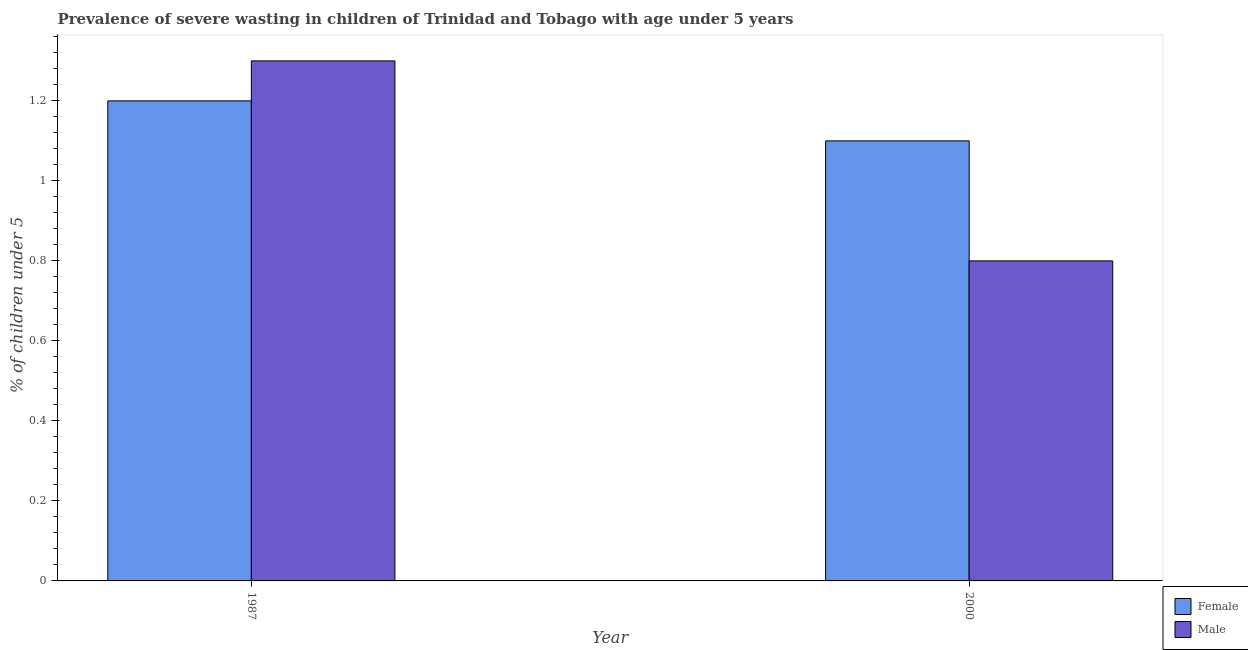How many different coloured bars are there?
Make the answer very short. 2. Are the number of bars per tick equal to the number of legend labels?
Your answer should be very brief. Yes. How many bars are there on the 1st tick from the right?
Give a very brief answer. 2. In how many cases, is the number of bars for a given year not equal to the number of legend labels?
Your answer should be very brief. 0. What is the percentage of undernourished female children in 1987?
Your response must be concise. 1.2. Across all years, what is the maximum percentage of undernourished male children?
Make the answer very short. 1.3. Across all years, what is the minimum percentage of undernourished female children?
Provide a short and direct response. 1.1. In which year was the percentage of undernourished female children maximum?
Make the answer very short. 1987. In which year was the percentage of undernourished male children minimum?
Your answer should be compact. 2000. What is the total percentage of undernourished male children in the graph?
Your answer should be compact. 2.1. What is the difference between the percentage of undernourished female children in 1987 and that in 2000?
Give a very brief answer. 0.1. What is the difference between the percentage of undernourished male children in 1987 and the percentage of undernourished female children in 2000?
Keep it short and to the point. 0.5. What is the average percentage of undernourished female children per year?
Your answer should be compact. 1.15. What is the ratio of the percentage of undernourished female children in 1987 to that in 2000?
Ensure brevity in your answer.  1.09. In how many years, is the percentage of undernourished male children greater than the average percentage of undernourished male children taken over all years?
Ensure brevity in your answer.  1. What does the 1st bar from the left in 1987 represents?
Make the answer very short. Female. What is the difference between two consecutive major ticks on the Y-axis?
Your answer should be compact. 0.2. Does the graph contain any zero values?
Provide a succinct answer. No. Where does the legend appear in the graph?
Your answer should be very brief. Bottom right. How are the legend labels stacked?
Provide a short and direct response. Vertical. What is the title of the graph?
Give a very brief answer. Prevalence of severe wasting in children of Trinidad and Tobago with age under 5 years. What is the label or title of the X-axis?
Give a very brief answer. Year. What is the label or title of the Y-axis?
Offer a very short reply.  % of children under 5. What is the  % of children under 5 in Female in 1987?
Give a very brief answer. 1.2. What is the  % of children under 5 in Male in 1987?
Offer a very short reply. 1.3. What is the  % of children under 5 in Female in 2000?
Offer a terse response. 1.1. What is the  % of children under 5 in Male in 2000?
Ensure brevity in your answer.  0.8. Across all years, what is the maximum  % of children under 5 in Female?
Your answer should be very brief. 1.2. Across all years, what is the maximum  % of children under 5 of Male?
Offer a very short reply. 1.3. Across all years, what is the minimum  % of children under 5 of Female?
Offer a very short reply. 1.1. Across all years, what is the minimum  % of children under 5 of Male?
Ensure brevity in your answer.  0.8. What is the total  % of children under 5 in Female in the graph?
Make the answer very short. 2.3. What is the average  % of children under 5 of Female per year?
Keep it short and to the point. 1.15. What is the ratio of the  % of children under 5 of Male in 1987 to that in 2000?
Your answer should be very brief. 1.62. What is the difference between the highest and the lowest  % of children under 5 in Female?
Provide a short and direct response. 0.1. What is the difference between the highest and the lowest  % of children under 5 in Male?
Your answer should be very brief. 0.5. 